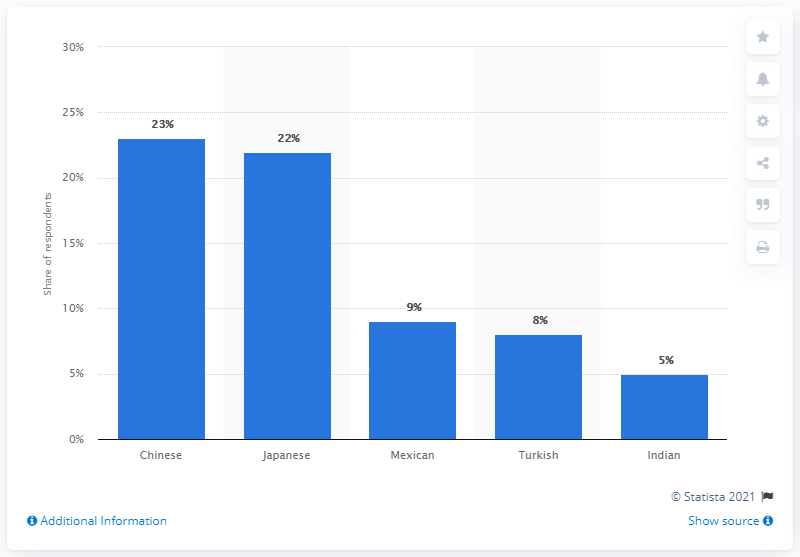Outline some significant characteristics in this image. The most popular ethnic cuisine in Italy in 2018 was Turkish. 